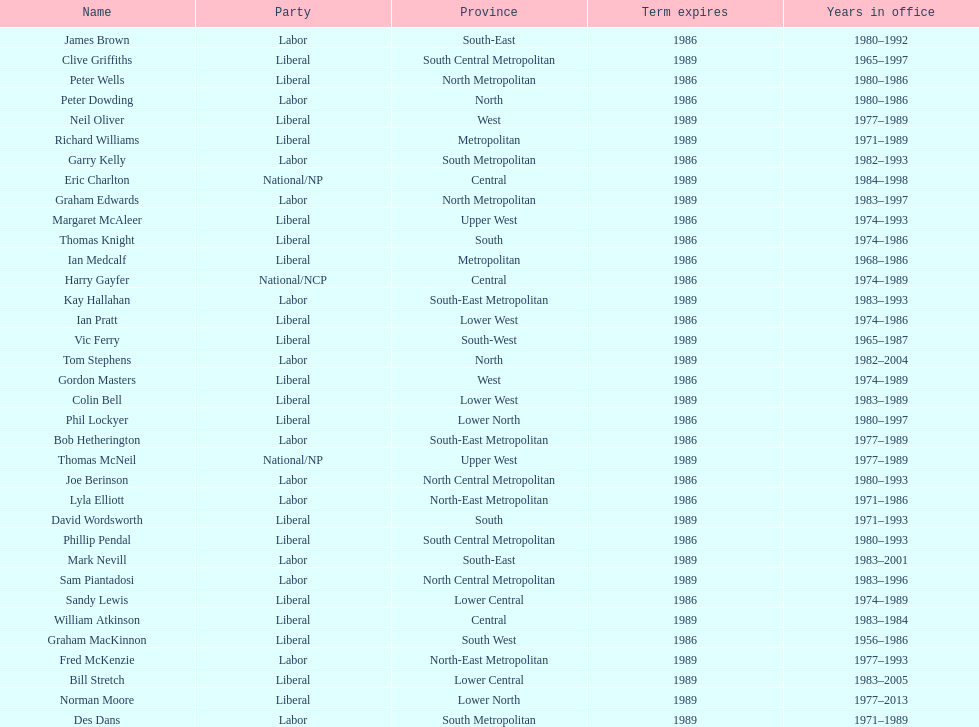How many members were party of lower west province? 2. 